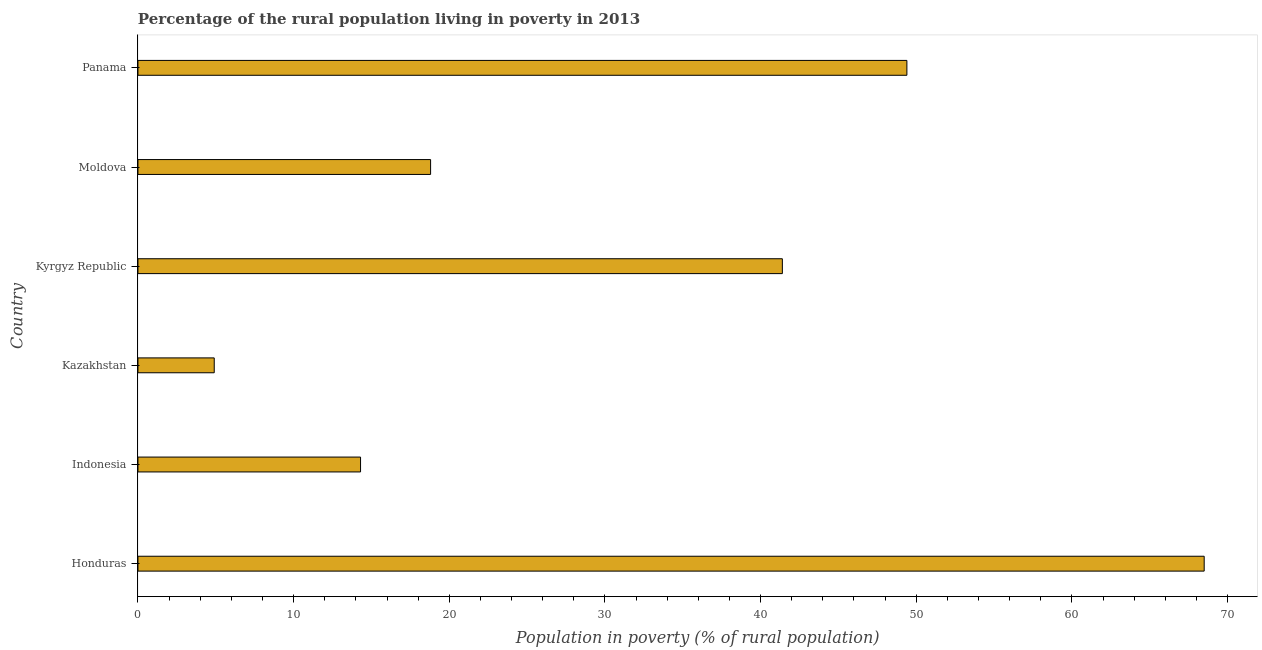What is the title of the graph?
Ensure brevity in your answer.  Percentage of the rural population living in poverty in 2013. What is the label or title of the X-axis?
Your answer should be compact. Population in poverty (% of rural population). What is the label or title of the Y-axis?
Provide a short and direct response. Country. What is the percentage of rural population living below poverty line in Moldova?
Your answer should be compact. 18.8. Across all countries, what is the maximum percentage of rural population living below poverty line?
Ensure brevity in your answer.  68.5. In which country was the percentage of rural population living below poverty line maximum?
Offer a very short reply. Honduras. In which country was the percentage of rural population living below poverty line minimum?
Your answer should be compact. Kazakhstan. What is the sum of the percentage of rural population living below poverty line?
Your response must be concise. 197.3. What is the difference between the percentage of rural population living below poverty line in Indonesia and Panama?
Your answer should be very brief. -35.1. What is the average percentage of rural population living below poverty line per country?
Provide a succinct answer. 32.88. What is the median percentage of rural population living below poverty line?
Ensure brevity in your answer.  30.1. What is the ratio of the percentage of rural population living below poverty line in Honduras to that in Kazakhstan?
Keep it short and to the point. 13.98. What is the difference between the highest and the second highest percentage of rural population living below poverty line?
Your answer should be very brief. 19.1. What is the difference between the highest and the lowest percentage of rural population living below poverty line?
Provide a succinct answer. 63.6. In how many countries, is the percentage of rural population living below poverty line greater than the average percentage of rural population living below poverty line taken over all countries?
Make the answer very short. 3. Are all the bars in the graph horizontal?
Your answer should be compact. Yes. What is the Population in poverty (% of rural population) in Honduras?
Your answer should be very brief. 68.5. What is the Population in poverty (% of rural population) in Indonesia?
Keep it short and to the point. 14.3. What is the Population in poverty (% of rural population) in Kyrgyz Republic?
Ensure brevity in your answer.  41.4. What is the Population in poverty (% of rural population) of Panama?
Offer a terse response. 49.4. What is the difference between the Population in poverty (% of rural population) in Honduras and Indonesia?
Your response must be concise. 54.2. What is the difference between the Population in poverty (% of rural population) in Honduras and Kazakhstan?
Ensure brevity in your answer.  63.6. What is the difference between the Population in poverty (% of rural population) in Honduras and Kyrgyz Republic?
Your answer should be very brief. 27.1. What is the difference between the Population in poverty (% of rural population) in Honduras and Moldova?
Provide a succinct answer. 49.7. What is the difference between the Population in poverty (% of rural population) in Indonesia and Kyrgyz Republic?
Keep it short and to the point. -27.1. What is the difference between the Population in poverty (% of rural population) in Indonesia and Moldova?
Ensure brevity in your answer.  -4.5. What is the difference between the Population in poverty (% of rural population) in Indonesia and Panama?
Ensure brevity in your answer.  -35.1. What is the difference between the Population in poverty (% of rural population) in Kazakhstan and Kyrgyz Republic?
Your answer should be compact. -36.5. What is the difference between the Population in poverty (% of rural population) in Kazakhstan and Panama?
Ensure brevity in your answer.  -44.5. What is the difference between the Population in poverty (% of rural population) in Kyrgyz Republic and Moldova?
Provide a short and direct response. 22.6. What is the difference between the Population in poverty (% of rural population) in Moldova and Panama?
Offer a very short reply. -30.6. What is the ratio of the Population in poverty (% of rural population) in Honduras to that in Indonesia?
Provide a short and direct response. 4.79. What is the ratio of the Population in poverty (% of rural population) in Honduras to that in Kazakhstan?
Provide a short and direct response. 13.98. What is the ratio of the Population in poverty (% of rural population) in Honduras to that in Kyrgyz Republic?
Your response must be concise. 1.66. What is the ratio of the Population in poverty (% of rural population) in Honduras to that in Moldova?
Ensure brevity in your answer.  3.64. What is the ratio of the Population in poverty (% of rural population) in Honduras to that in Panama?
Keep it short and to the point. 1.39. What is the ratio of the Population in poverty (% of rural population) in Indonesia to that in Kazakhstan?
Provide a succinct answer. 2.92. What is the ratio of the Population in poverty (% of rural population) in Indonesia to that in Kyrgyz Republic?
Provide a short and direct response. 0.34. What is the ratio of the Population in poverty (% of rural population) in Indonesia to that in Moldova?
Your answer should be very brief. 0.76. What is the ratio of the Population in poverty (% of rural population) in Indonesia to that in Panama?
Provide a succinct answer. 0.29. What is the ratio of the Population in poverty (% of rural population) in Kazakhstan to that in Kyrgyz Republic?
Make the answer very short. 0.12. What is the ratio of the Population in poverty (% of rural population) in Kazakhstan to that in Moldova?
Ensure brevity in your answer.  0.26. What is the ratio of the Population in poverty (% of rural population) in Kazakhstan to that in Panama?
Your answer should be compact. 0.1. What is the ratio of the Population in poverty (% of rural population) in Kyrgyz Republic to that in Moldova?
Offer a terse response. 2.2. What is the ratio of the Population in poverty (% of rural population) in Kyrgyz Republic to that in Panama?
Provide a succinct answer. 0.84. What is the ratio of the Population in poverty (% of rural population) in Moldova to that in Panama?
Give a very brief answer. 0.38. 